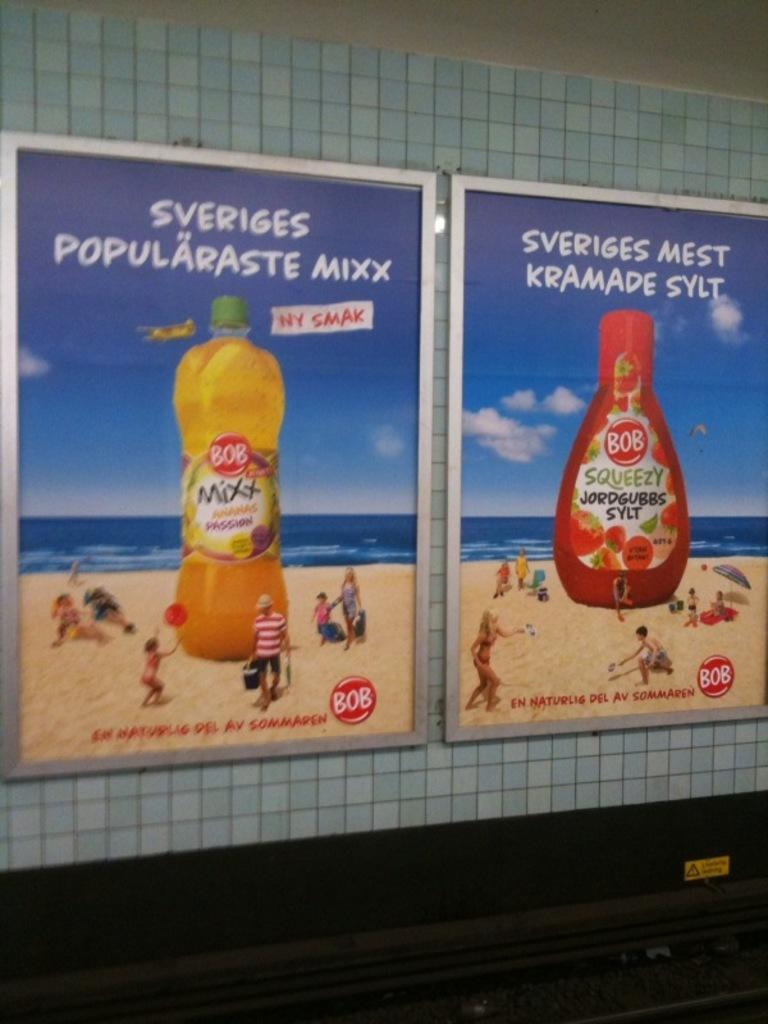<image>
Give a short and clear explanation of the subsequent image. A poster of BOB MIXX which says SVERIGES POPULARASTE MIXX. 